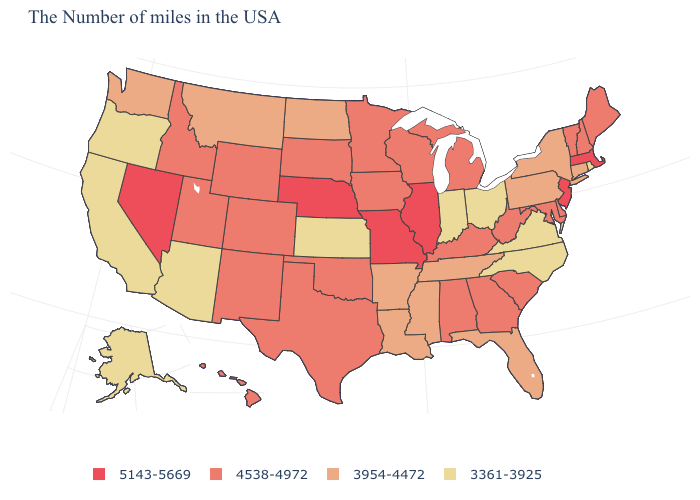Name the states that have a value in the range 5143-5669?
Keep it brief. Massachusetts, New Jersey, Illinois, Missouri, Nebraska, Nevada. Is the legend a continuous bar?
Quick response, please. No. Among the states that border Arizona , which have the highest value?
Give a very brief answer. Nevada. What is the value of Michigan?
Be succinct. 4538-4972. Name the states that have a value in the range 3954-4472?
Short answer required. Connecticut, New York, Pennsylvania, Florida, Tennessee, Mississippi, Louisiana, Arkansas, North Dakota, Montana, Washington. Does Connecticut have the highest value in the USA?
Be succinct. No. Name the states that have a value in the range 3954-4472?
Keep it brief. Connecticut, New York, Pennsylvania, Florida, Tennessee, Mississippi, Louisiana, Arkansas, North Dakota, Montana, Washington. Among the states that border Maryland , does Virginia have the lowest value?
Short answer required. Yes. What is the highest value in the West ?
Keep it brief. 5143-5669. What is the value of Pennsylvania?
Answer briefly. 3954-4472. Does the first symbol in the legend represent the smallest category?
Be succinct. No. Among the states that border Rhode Island , which have the highest value?
Write a very short answer. Massachusetts. What is the value of North Carolina?
Be succinct. 3361-3925. Does Missouri have the highest value in the MidWest?
Give a very brief answer. Yes. Does Tennessee have the lowest value in the USA?
Short answer required. No. 